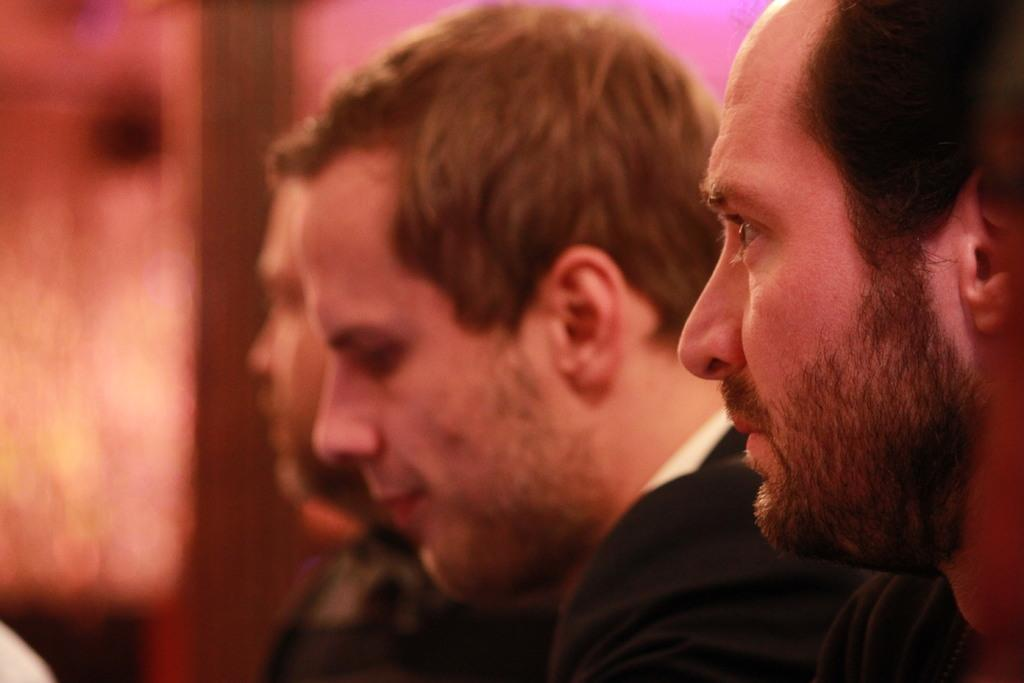How many people are in the image? There are three persons in the image. Can you describe the background of the image? The background of the image is blurry. What type of acoustics can be heard in the image? There is no information about any sounds or acoustics in the image, as it only features three persons and a blurry background. Can you tell me how many beads are visible in the image? There are no beads present in the image. 